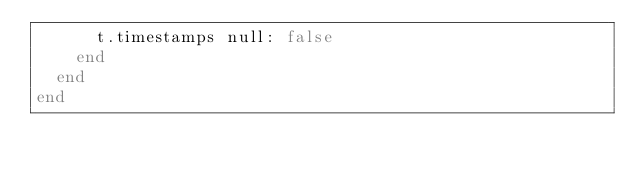<code> <loc_0><loc_0><loc_500><loc_500><_Ruby_>      t.timestamps null: false
    end
  end
end
</code> 